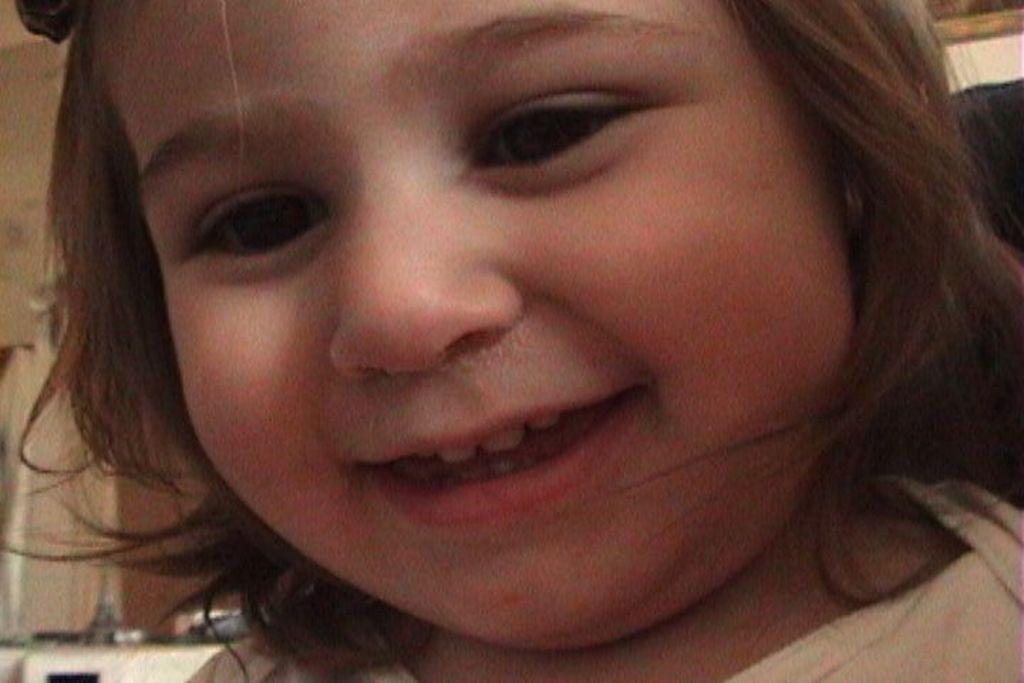Can you describe this image briefly? In this picture there is a girl who is wearing white dress, she is smiling. On the bottom left we can see some objects on the kitchen platform. 